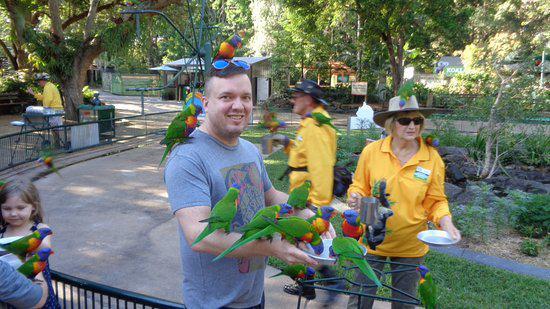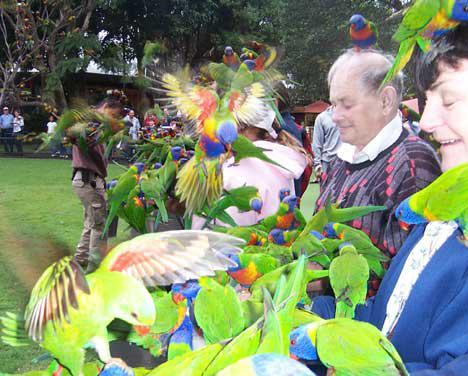The first image is the image on the left, the second image is the image on the right. Given the left and right images, does the statement "Birds are perched on a person in the image on the left." hold true? Answer yes or no. Yes. The first image is the image on the left, the second image is the image on the right. For the images shown, is this caption "At least one image shows multiple parrots with beaks bent toward a round pan and does not show any human faces." true? Answer yes or no. No. 